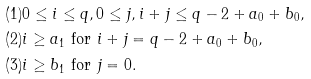Convert formula to latex. <formula><loc_0><loc_0><loc_500><loc_500>( 1 ) & 0 \leq i \leq q , 0 \leq j , i + j \leq q - 2 + a _ { 0 } + b _ { 0 } , \\ ( 2 ) & i \geq a _ { 1 } \text { for } i + j = q - 2 + a _ { 0 } + b _ { 0 } , \\ ( 3 ) & i \geq b _ { 1 } \text { for } j = 0 . \\</formula> 